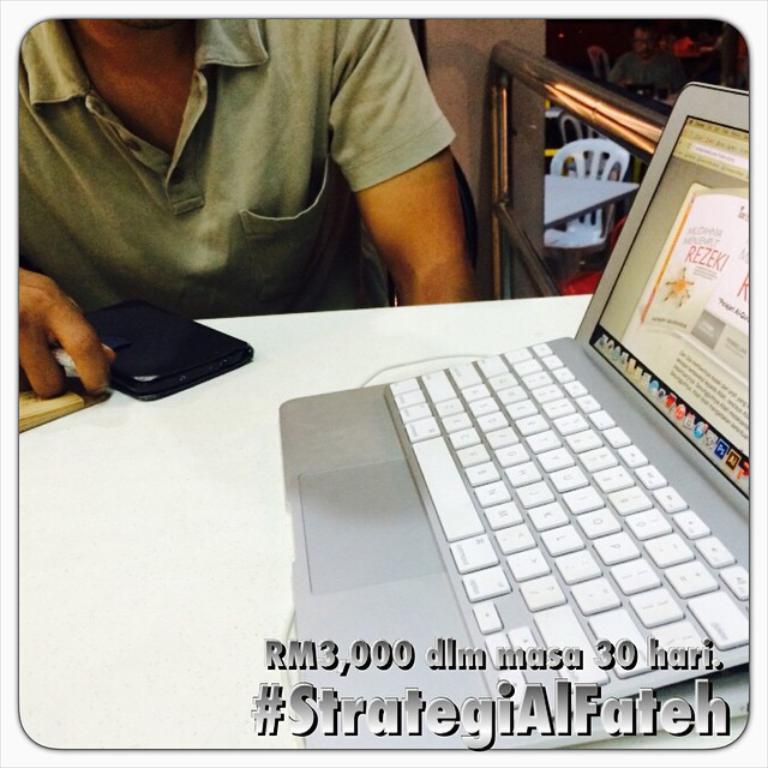What numbers are shown?
Ensure brevity in your answer.  3,000 30. What is the hashtag?
Keep it short and to the point. #strategialfateh. 